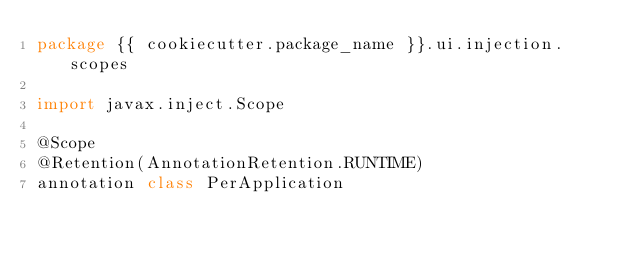Convert code to text. <code><loc_0><loc_0><loc_500><loc_500><_Kotlin_>package {{ cookiecutter.package_name }}.ui.injection.scopes

import javax.inject.Scope

@Scope
@Retention(AnnotationRetention.RUNTIME)
annotation class PerApplication</code> 